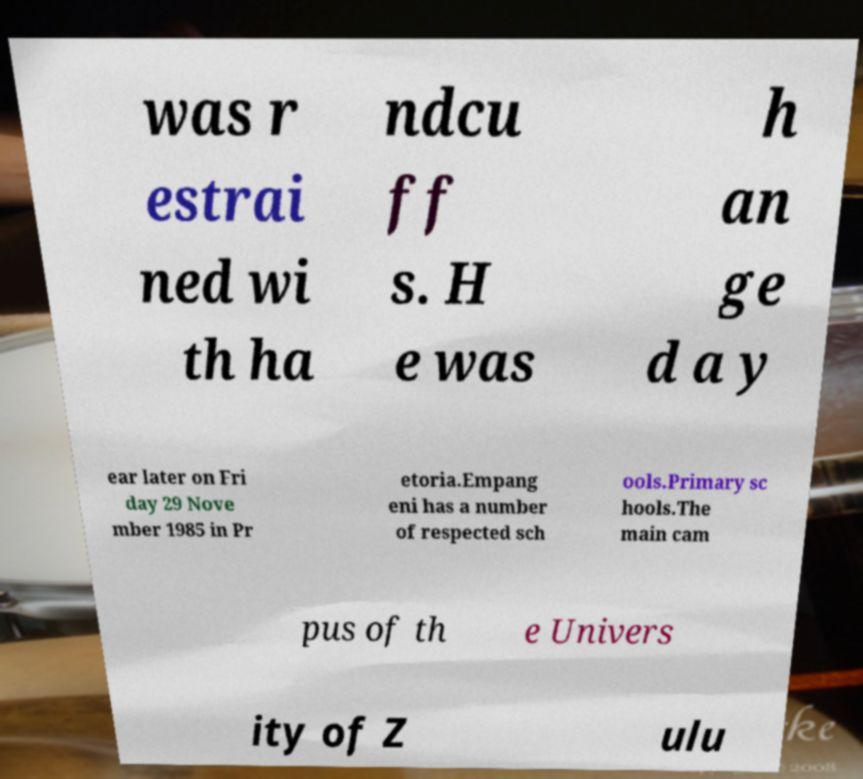Can you accurately transcribe the text from the provided image for me? was r estrai ned wi th ha ndcu ff s. H e was h an ge d a y ear later on Fri day 29 Nove mber 1985 in Pr etoria.Empang eni has a number of respected sch ools.Primary sc hools.The main cam pus of th e Univers ity of Z ulu 